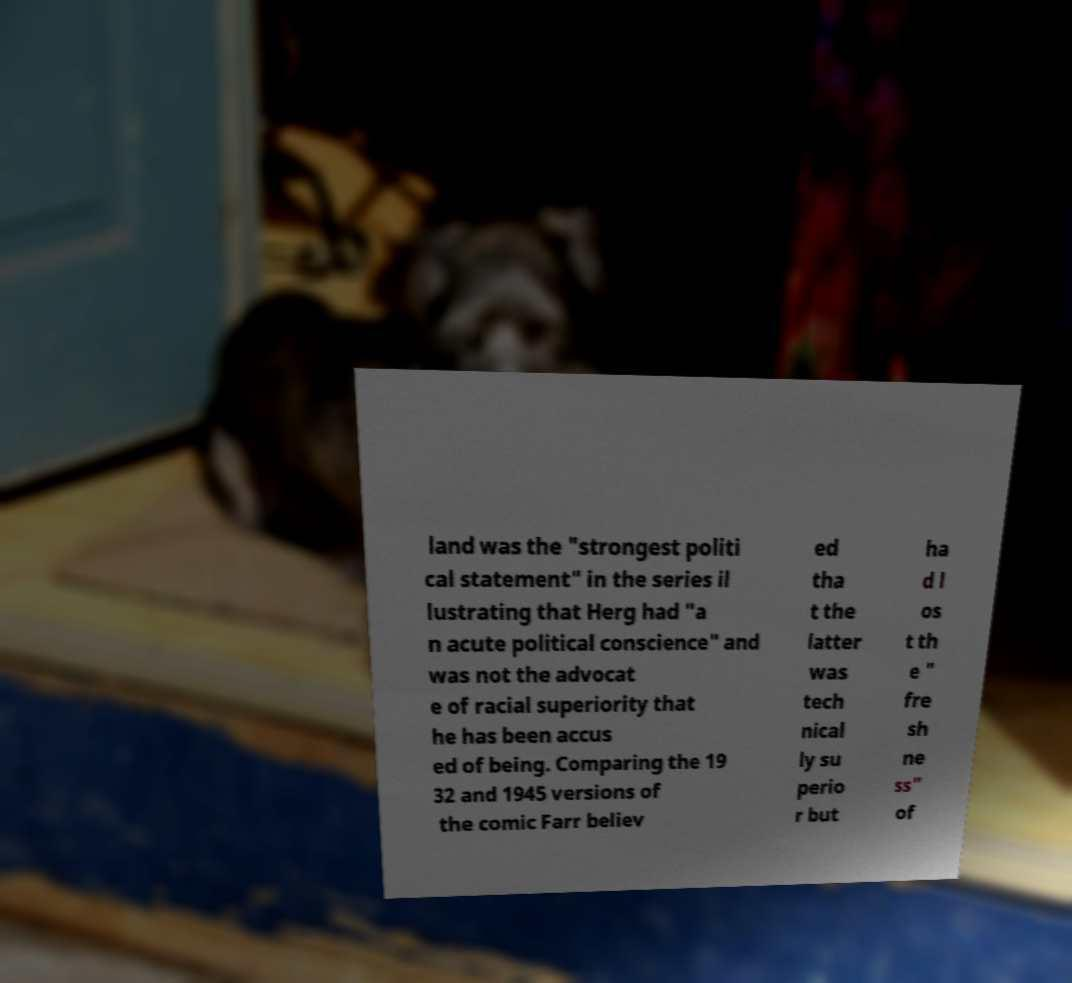Please read and relay the text visible in this image. What does it say? land was the "strongest politi cal statement" in the series il lustrating that Herg had "a n acute political conscience" and was not the advocat e of racial superiority that he has been accus ed of being. Comparing the 19 32 and 1945 versions of the comic Farr believ ed tha t the latter was tech nical ly su perio r but ha d l os t th e " fre sh ne ss" of 